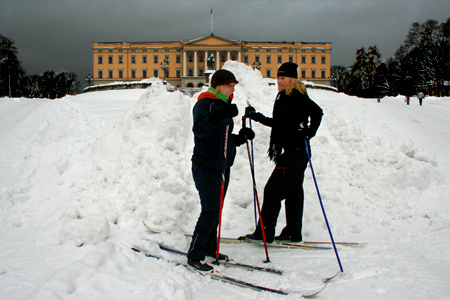Is the color of the cap different than the color of the jacket? No, the color of the cap is not different from the color of the jacket; both are black. 